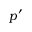Convert formula to latex. <formula><loc_0><loc_0><loc_500><loc_500>p ^ { \prime }</formula> 